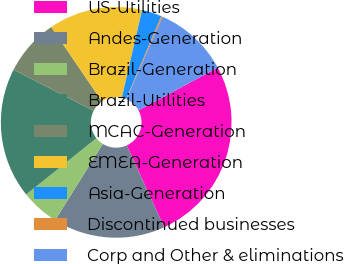Convert chart. <chart><loc_0><loc_0><loc_500><loc_500><pie_chart><fcel>US-Utilities<fcel>Andes-Generation<fcel>Brazil-Generation<fcel>Brazil-Utilities<fcel>MCAC-Generation<fcel>EMEA-Generation<fcel>Asia-Generation<fcel>Discontinued businesses<fcel>Corp and Other & eliminations<nl><fcel>26.05%<fcel>15.71%<fcel>5.37%<fcel>18.29%<fcel>7.95%<fcel>13.12%<fcel>2.78%<fcel>0.2%<fcel>10.54%<nl></chart> 